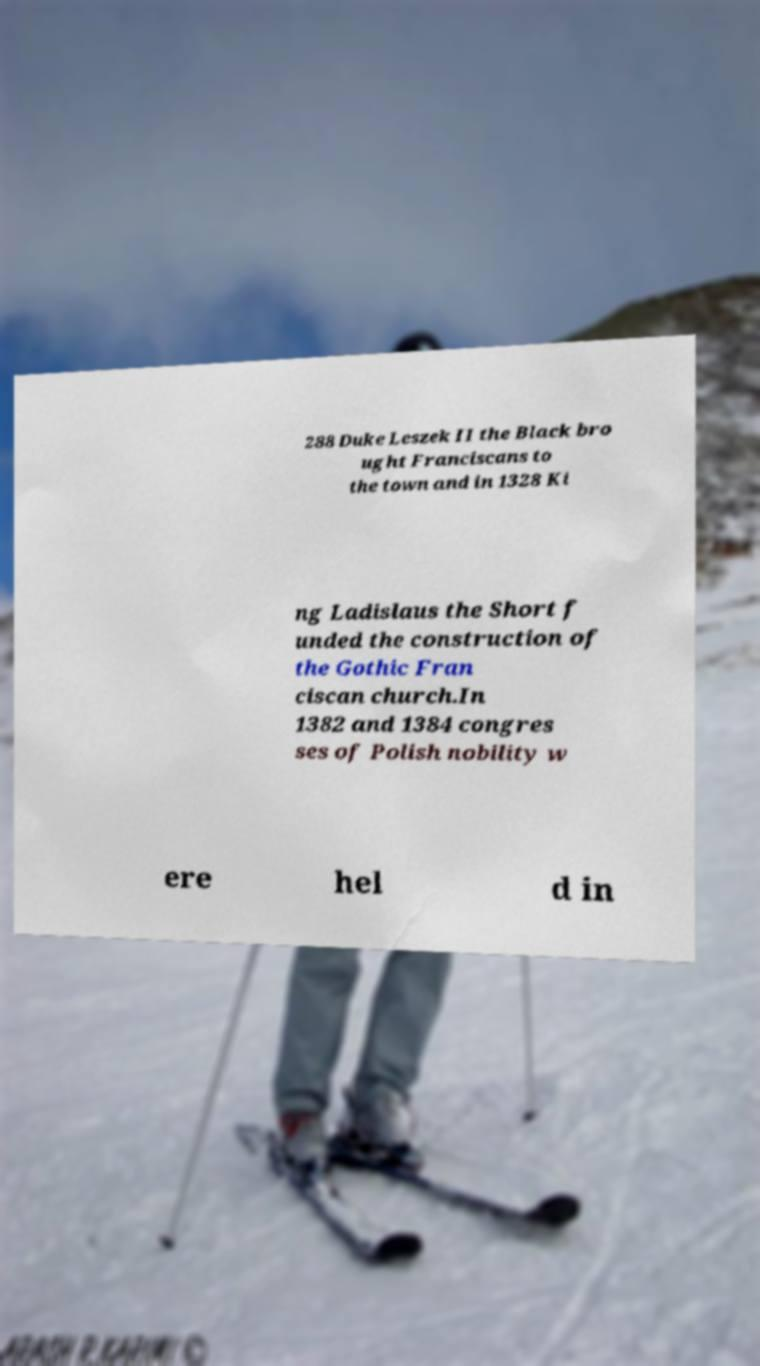Could you extract and type out the text from this image? 288 Duke Leszek II the Black bro ught Franciscans to the town and in 1328 Ki ng Ladislaus the Short f unded the construction of the Gothic Fran ciscan church.In 1382 and 1384 congres ses of Polish nobility w ere hel d in 